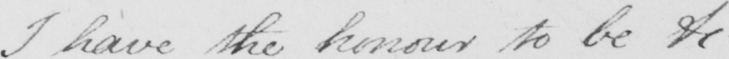Can you read and transcribe this handwriting? I have the honour to be &c  _ 